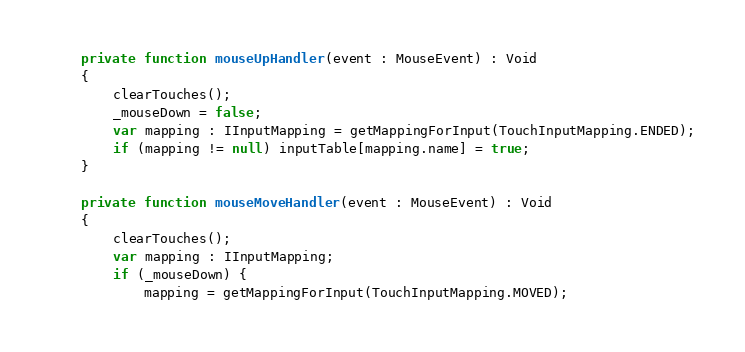<code> <loc_0><loc_0><loc_500><loc_500><_Haxe_>	private function mouseUpHandler(event : MouseEvent) : Void
	{
		clearTouches();
		_mouseDown = false;
		var mapping : IInputMapping = getMappingForInput(TouchInputMapping.ENDED);
		if (mapping != null) inputTable[mapping.name] = true;
	}
	
	private function mouseMoveHandler(event : MouseEvent) : Void
	{
		clearTouches();
		var mapping : IInputMapping;
		if (_mouseDown) {
			mapping = getMappingForInput(TouchInputMapping.MOVED);</code> 